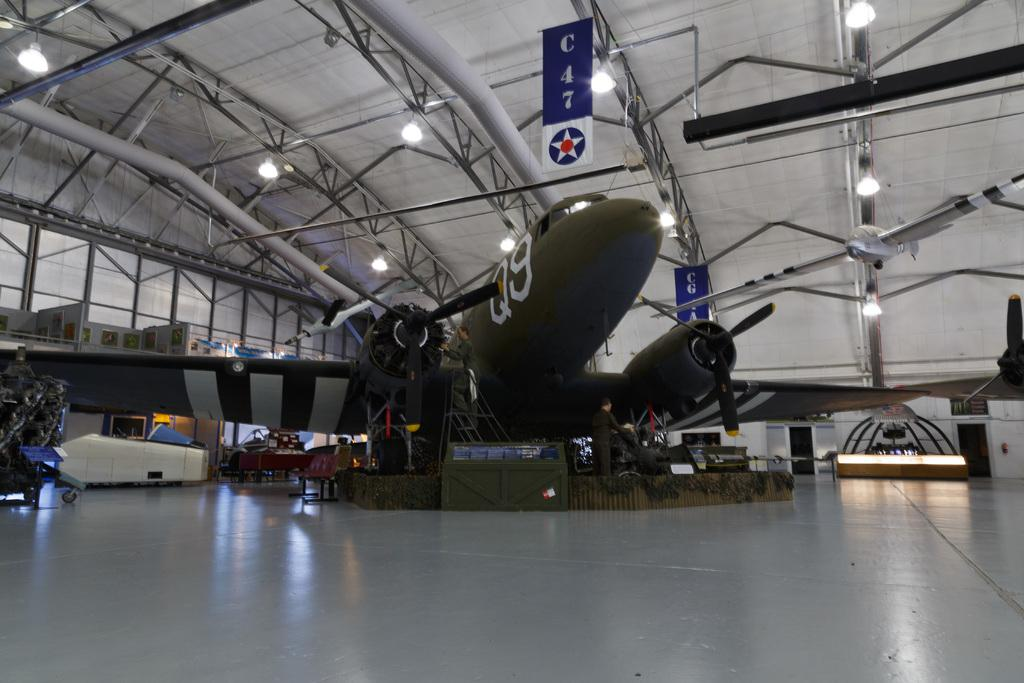Provide a one-sentence caption for the provided image. An airplane with Q9 on its side sits in a hangar. 